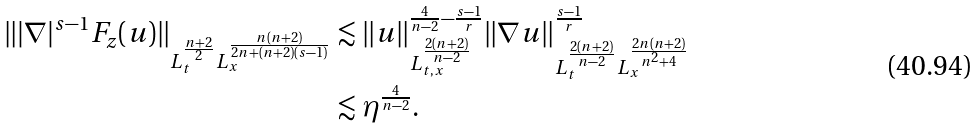Convert formula to latex. <formula><loc_0><loc_0><loc_500><loc_500>\| | \nabla | ^ { s - 1 } F _ { z } ( u ) \| _ { L _ { t } ^ { \frac { n + 2 } { 2 } } L _ { x } ^ { \frac { n ( n + 2 ) } { 2 n + ( n + 2 ) ( s - 1 ) } } } & \lesssim \| u \| _ { L _ { t , x } ^ { \frac { 2 ( n + 2 ) } { n - 2 } } } ^ { \frac { 4 } { n - 2 } - \frac { s - 1 } { r } } \| \nabla u \| _ { L _ { t } ^ { \frac { 2 ( n + 2 ) } { n - 2 } } L _ { x } ^ { \frac { 2 n ( n + 2 ) } { n ^ { 2 } + 4 } } } ^ { \frac { s - 1 } { r } } \\ & \lesssim \eta ^ { \frac { 4 } { n - 2 } } .</formula> 